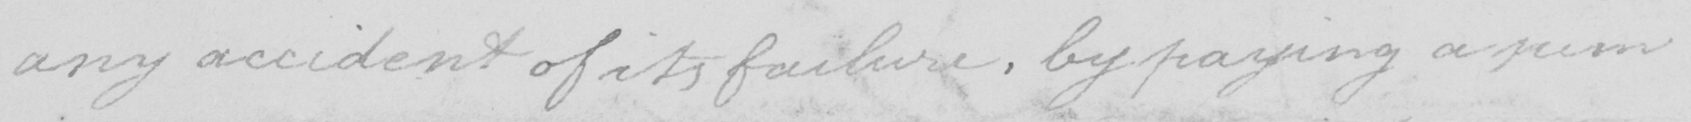Can you read and transcribe this handwriting? any accident of its failure , by paying a sum 